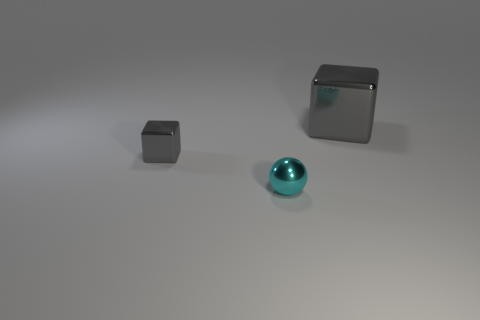Are there an equal number of big gray metallic cubes that are behind the cyan shiny sphere and cyan metal things left of the large gray cube?
Make the answer very short. Yes. What color is the small cube that is the same material as the tiny cyan thing?
Offer a terse response. Gray. Is the color of the small cube the same as the metal thing on the right side of the small cyan shiny sphere?
Your answer should be very brief. Yes. There is a small metal sphere left of the gray block on the right side of the tiny cube; are there any small objects that are left of it?
Make the answer very short. Yes. There is a tiny cyan object that is made of the same material as the tiny gray block; what is its shape?
Your response must be concise. Sphere. Is there anything else that has the same shape as the large thing?
Make the answer very short. Yes. The tiny gray thing is what shape?
Give a very brief answer. Cube. Does the tiny shiny object that is in front of the small gray metallic cube have the same shape as the small gray thing?
Your answer should be compact. No. Is the number of objects that are in front of the small cyan ball greater than the number of gray cubes to the left of the big shiny thing?
Your response must be concise. No. How many other things are the same size as the cyan object?
Your answer should be compact. 1. 